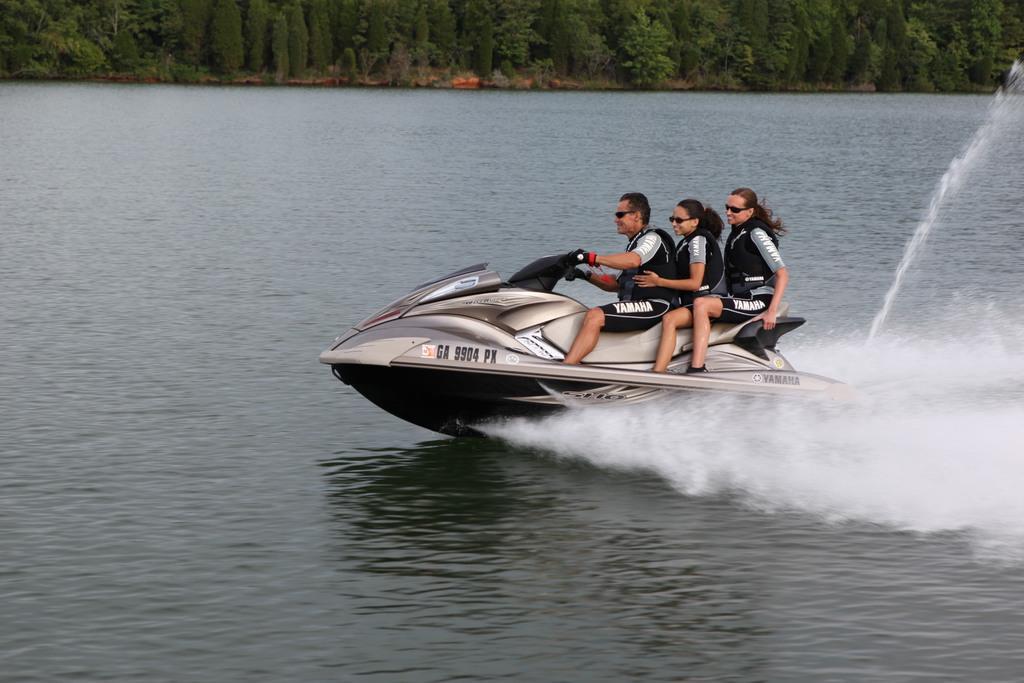Please provide a concise description of this image. In this image a person is driving a speed boat and two people are sitting behind them, there are trees in the background. 